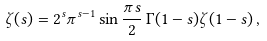<formula> <loc_0><loc_0><loc_500><loc_500>\zeta ( s ) = 2 ^ { s } \pi ^ { s - 1 } \sin { \frac { \pi s } { 2 } } \, \Gamma ( 1 - s ) \zeta ( 1 - s ) \, ,</formula> 